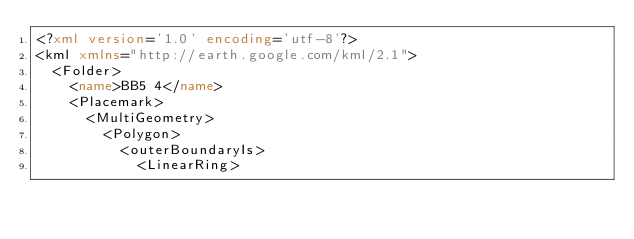Convert code to text. <code><loc_0><loc_0><loc_500><loc_500><_XML_><?xml version='1.0' encoding='utf-8'?>
<kml xmlns="http://earth.google.com/kml/2.1">
  <Folder>
    <name>BB5 4</name>
    <Placemark>
      <MultiGeometry>
        <Polygon>
          <outerBoundaryIs>
            <LinearRing></code> 